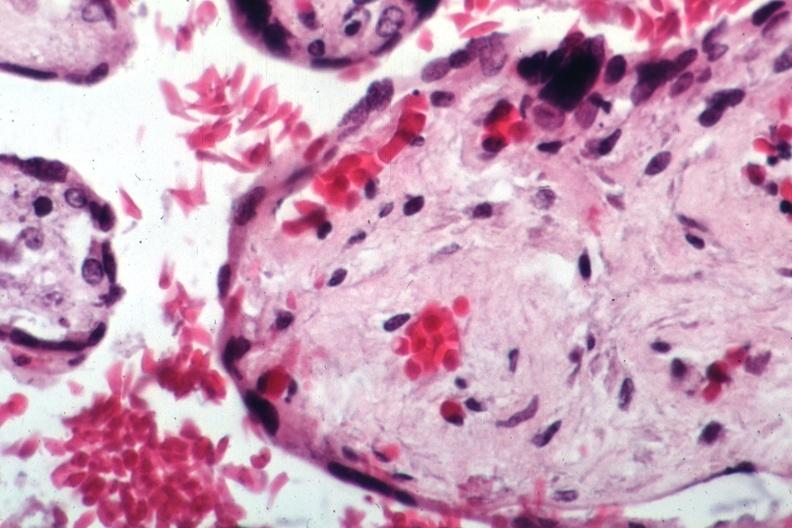s placenta present?
Answer the question using a single word or phrase. Yes 